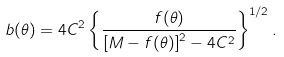Convert formula to latex. <formula><loc_0><loc_0><loc_500><loc_500>b ( \theta ) = 4 C ^ { 2 } \left \{ \frac { f ( \theta ) } { \left [ M - f ( \theta ) \right ] ^ { 2 } - 4 C ^ { 2 } } \right \} ^ { 1 / 2 } .</formula> 